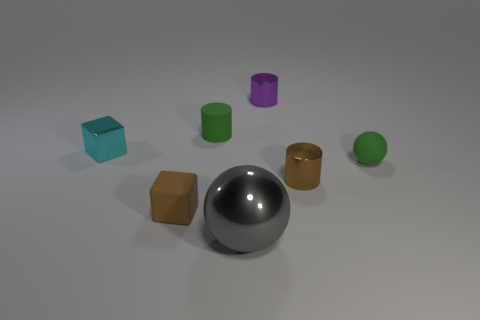Do the tiny cyan cube that is behind the green rubber ball and the brown thing on the right side of the tiny purple metal object have the same material?
Make the answer very short. Yes. The cyan metallic thing has what shape?
Offer a very short reply. Cube. Is the number of small cylinders in front of the purple cylinder the same as the number of small purple blocks?
Offer a very short reply. No. The matte cylinder that is the same color as the rubber sphere is what size?
Keep it short and to the point. Small. Are there any purple things that have the same material as the green sphere?
Your response must be concise. No. There is a small thing that is to the left of the matte cube; is it the same shape as the tiny brown object that is to the right of the gray sphere?
Your answer should be compact. No. Are any large cyan objects visible?
Give a very brief answer. No. There is a rubber cylinder that is the same size as the green sphere; what color is it?
Your answer should be compact. Green. What number of other gray things have the same shape as the big gray thing?
Keep it short and to the point. 0. Are the tiny brown thing that is left of the brown shiny cylinder and the purple cylinder made of the same material?
Your answer should be very brief. No. 